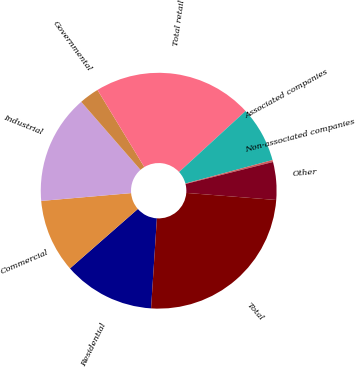Convert chart. <chart><loc_0><loc_0><loc_500><loc_500><pie_chart><fcel>Residential<fcel>Commercial<fcel>Industrial<fcel>Governmental<fcel>Total retail<fcel>Associated companies<fcel>Non-associated companies<fcel>Other<fcel>Total<nl><fcel>12.52%<fcel>10.07%<fcel>14.97%<fcel>2.72%<fcel>21.87%<fcel>7.62%<fcel>0.27%<fcel>5.17%<fcel>24.77%<nl></chart> 